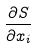<formula> <loc_0><loc_0><loc_500><loc_500>\frac { \partial S } { \partial x _ { i } }</formula> 